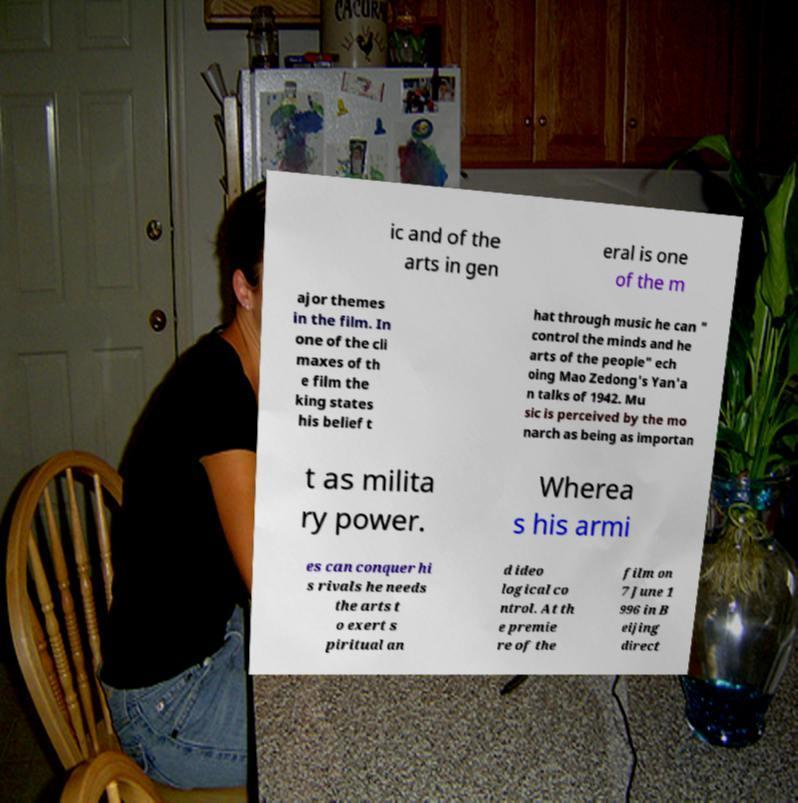Please read and relay the text visible in this image. What does it say? ic and of the arts in gen eral is one of the m ajor themes in the film. In one of the cli maxes of th e film the king states his belief t hat through music he can " control the minds and he arts of the people" ech oing Mao Zedong's Yan'a n talks of 1942. Mu sic is perceived by the mo narch as being as importan t as milita ry power. Wherea s his armi es can conquer hi s rivals he needs the arts t o exert s piritual an d ideo logical co ntrol. At th e premie re of the film on 7 June 1 996 in B eijing direct 